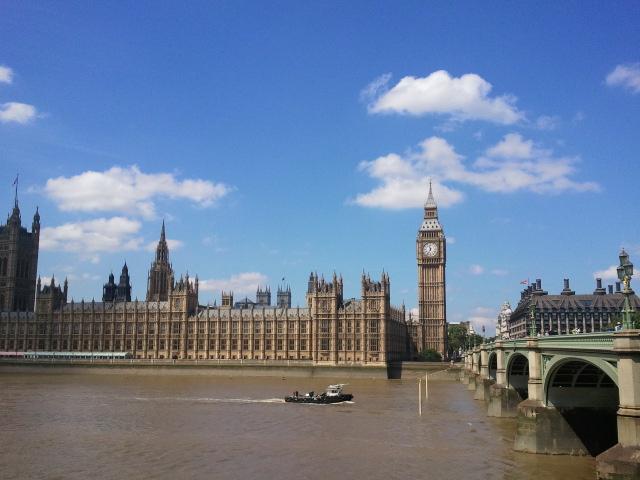Based on the size of the wake what is the approximate speed of the boat?
Keep it brief. 30 mph. Is this a lake?
Write a very short answer. No. How many clocks are pictured?
Keep it brief. 1. How many clocks are there?
Answer briefly. 1. Is this where Queen Elizabeth lives?
Short answer required. Yes. 